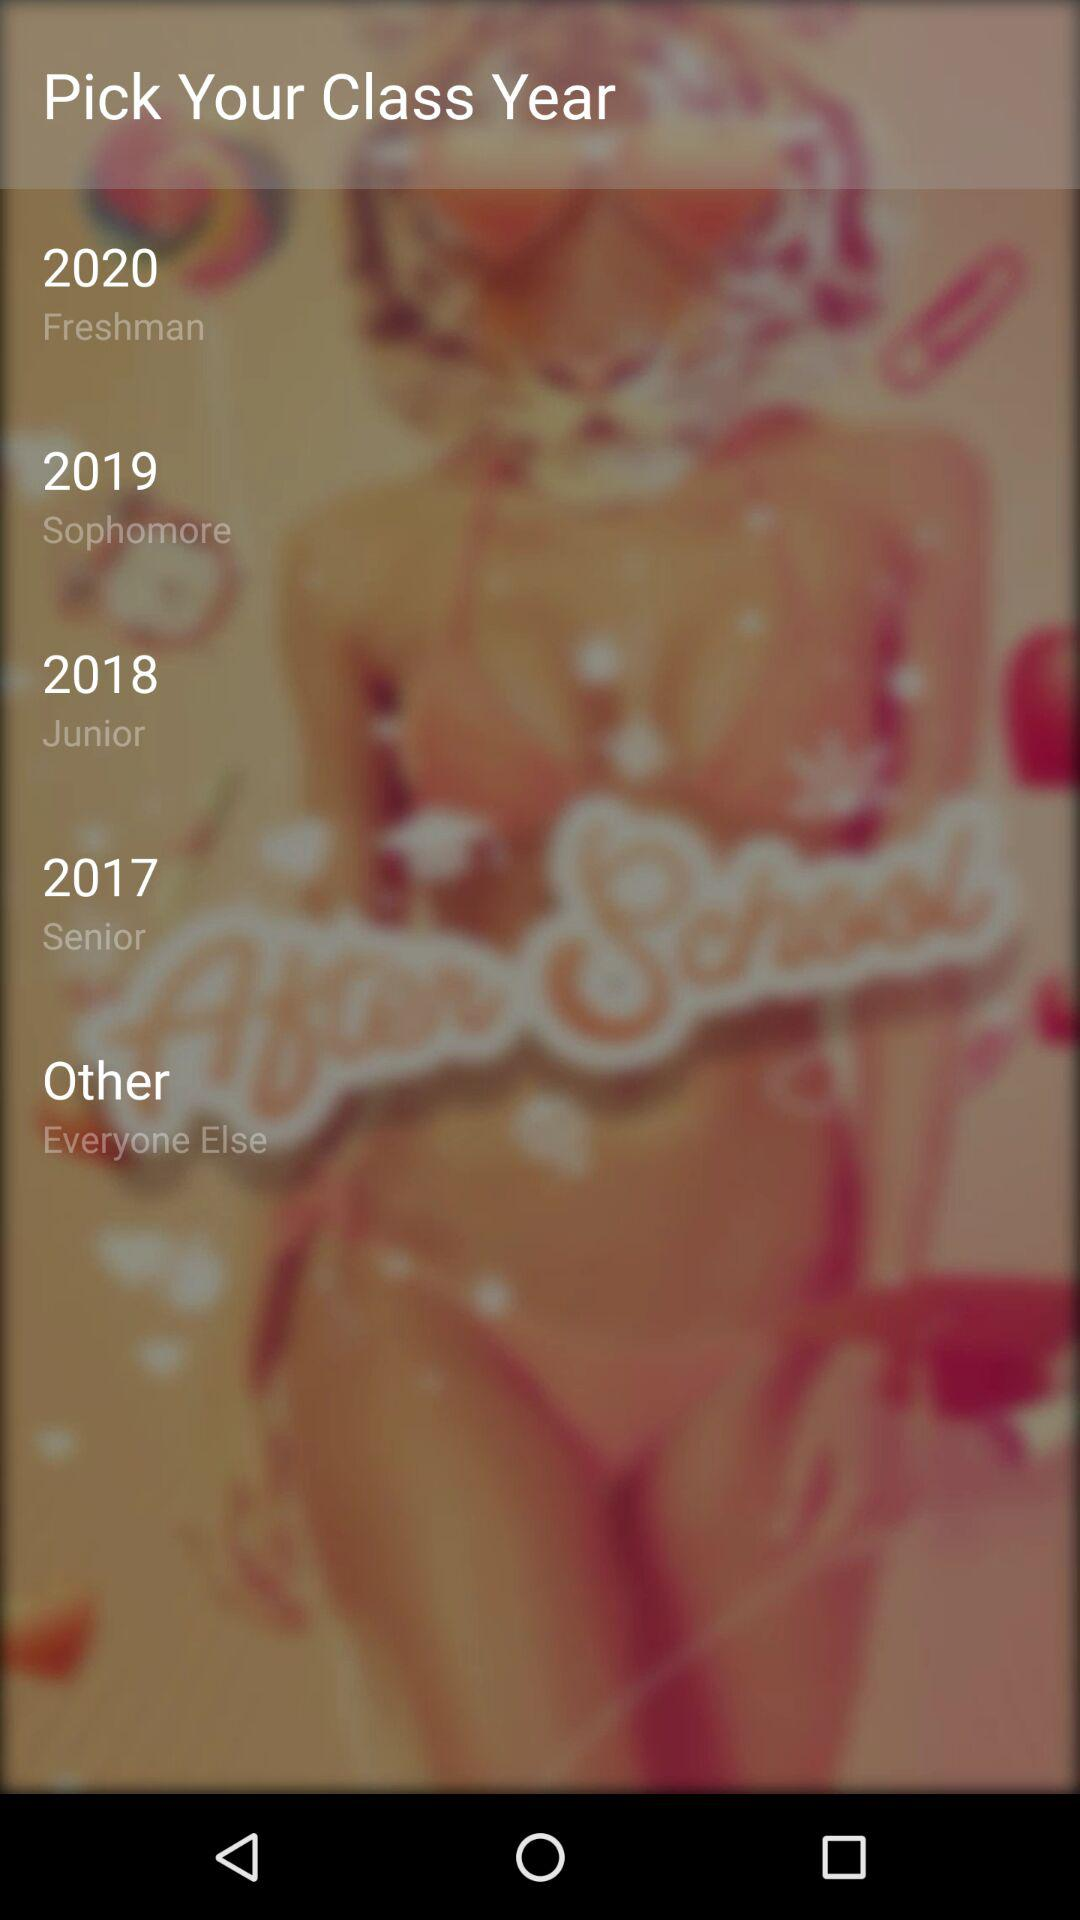Which is the freshman year? The freshman year is 2020. 